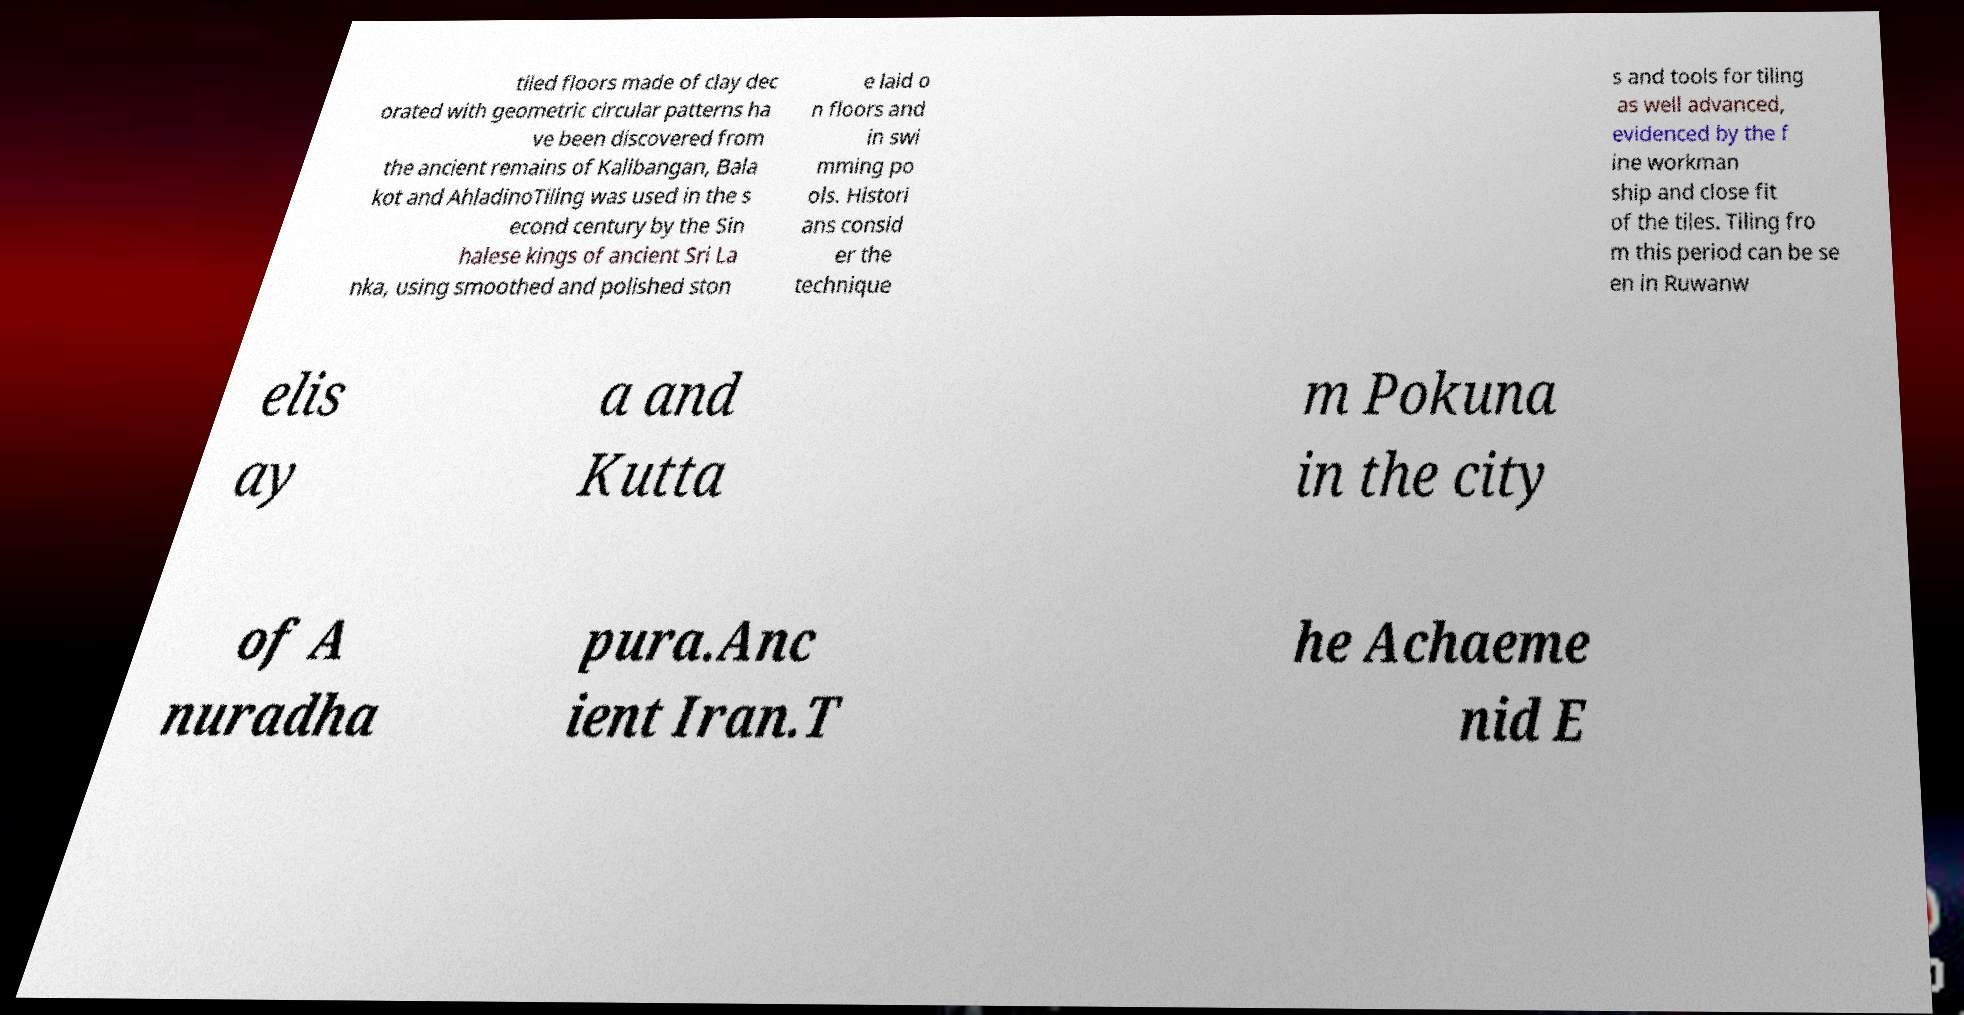Can you read and provide the text displayed in the image?This photo seems to have some interesting text. Can you extract and type it out for me? tiled floors made of clay dec orated with geometric circular patterns ha ve been discovered from the ancient remains of Kalibangan, Bala kot and AhladinoTiling was used in the s econd century by the Sin halese kings of ancient Sri La nka, using smoothed and polished ston e laid o n floors and in swi mming po ols. Histori ans consid er the technique s and tools for tiling as well advanced, evidenced by the f ine workman ship and close fit of the tiles. Tiling fro m this period can be se en in Ruwanw elis ay a and Kutta m Pokuna in the city of A nuradha pura.Anc ient Iran.T he Achaeme nid E 